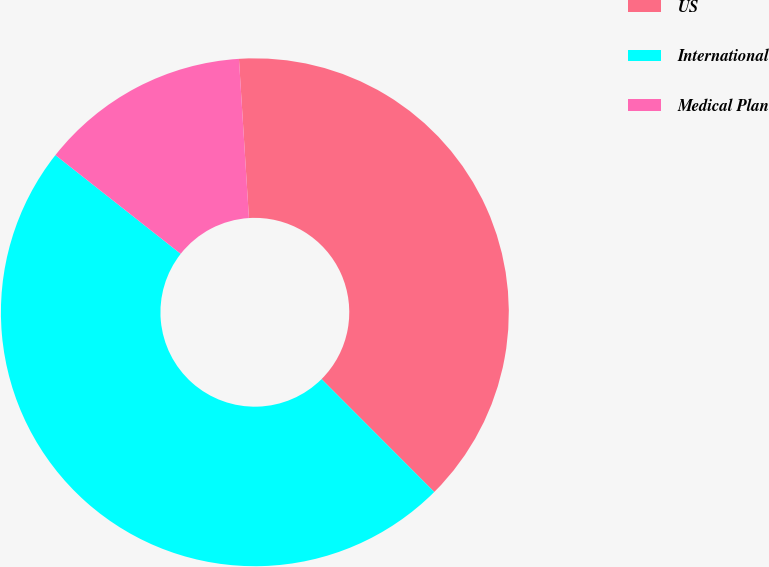<chart> <loc_0><loc_0><loc_500><loc_500><pie_chart><fcel>US<fcel>International<fcel>Medical Plan<nl><fcel>38.51%<fcel>48.11%<fcel>13.38%<nl></chart> 